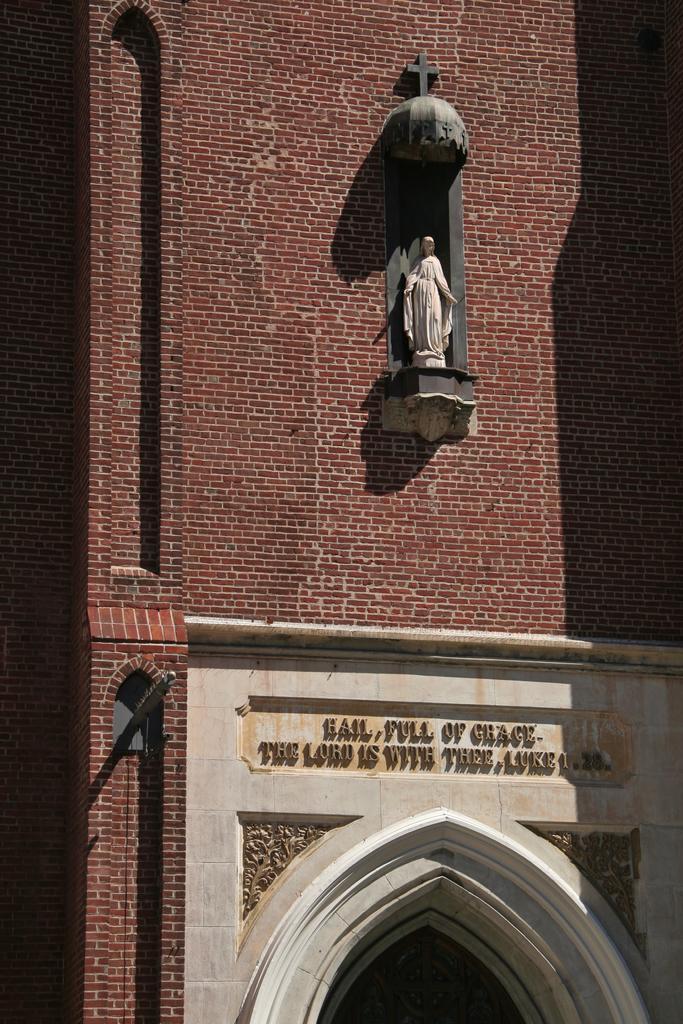How would you summarize this image in a sentence or two? This is the picture of a building. In this image there is a statue on the building and there is a text on the wall. 